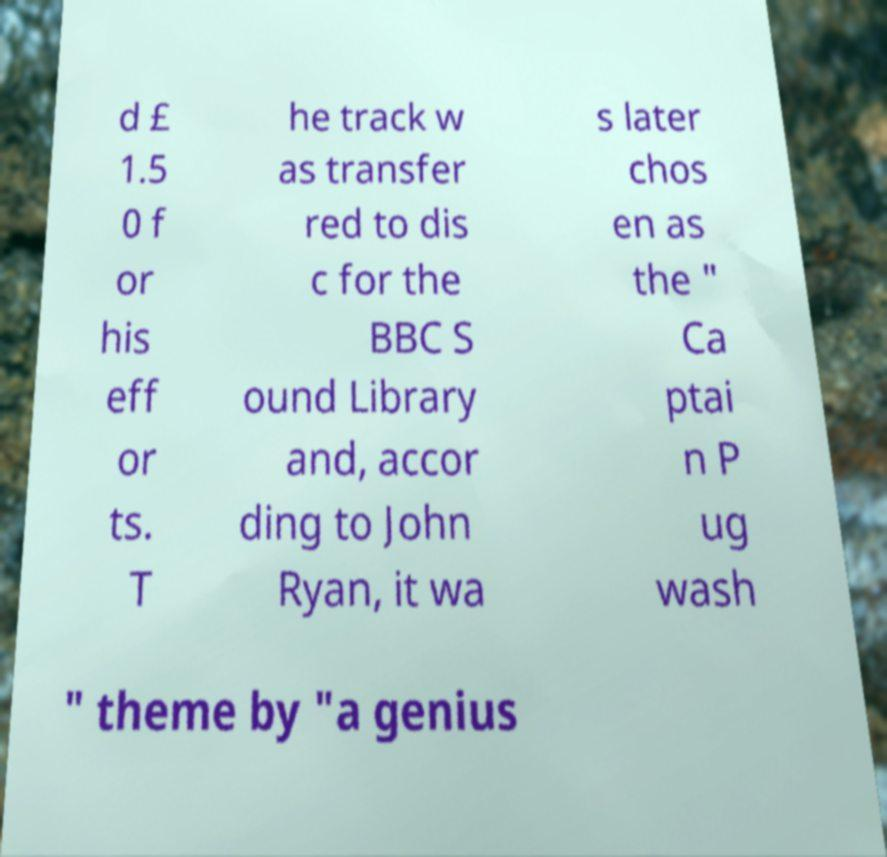Please identify and transcribe the text found in this image. d £ 1.5 0 f or his eff or ts. T he track w as transfer red to dis c for the BBC S ound Library and, accor ding to John Ryan, it wa s later chos en as the " Ca ptai n P ug wash " theme by "a genius 